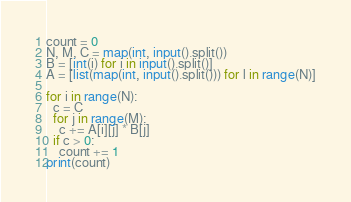<code> <loc_0><loc_0><loc_500><loc_500><_Python_>count = 0
N, M, C = map(int, input().split())
B = [int(i) for i in input().split()]
A = [list(map(int, input().split())) for l in range(N)]

for i in range(N):
  c = C
  for j in range(M):
    c += A[i][j] * B[j]
  if c > 0:
    count += 1
print(count)</code> 